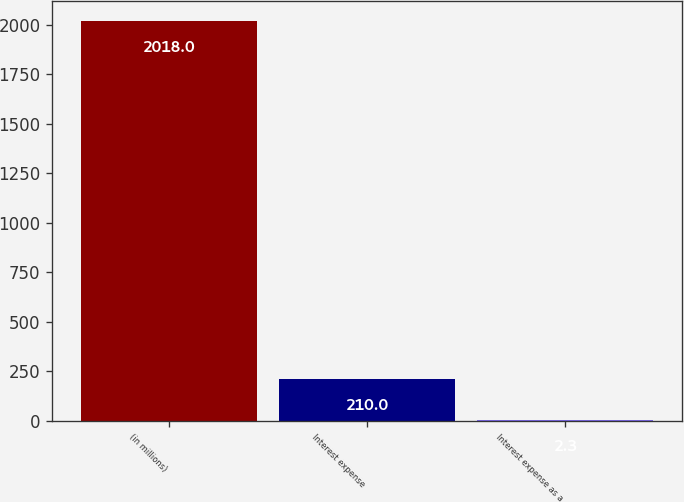Convert chart. <chart><loc_0><loc_0><loc_500><loc_500><bar_chart><fcel>(in millions)<fcel>Interest expense<fcel>Interest expense as a<nl><fcel>2018<fcel>210<fcel>2.3<nl></chart> 